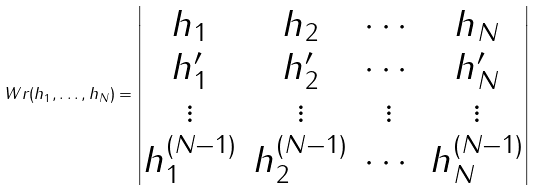<formula> <loc_0><loc_0><loc_500><loc_500>\ W r ( h _ { 1 } , \dots , h _ { N } ) = \left | \begin{matrix} h _ { 1 } & h _ { 2 } & \cdots & h _ { N } \\ h _ { 1 } ^ { \prime } & h _ { 2 } ^ { \prime } & \cdots & h _ { N } ^ { \prime } \\ \vdots & \vdots & \vdots & \vdots \\ h _ { 1 } ^ { ( N - 1 ) } & h _ { 2 } ^ { ( N - 1 ) } & \cdots & h _ { N } ^ { ( N - 1 ) } \end{matrix} \right |</formula> 